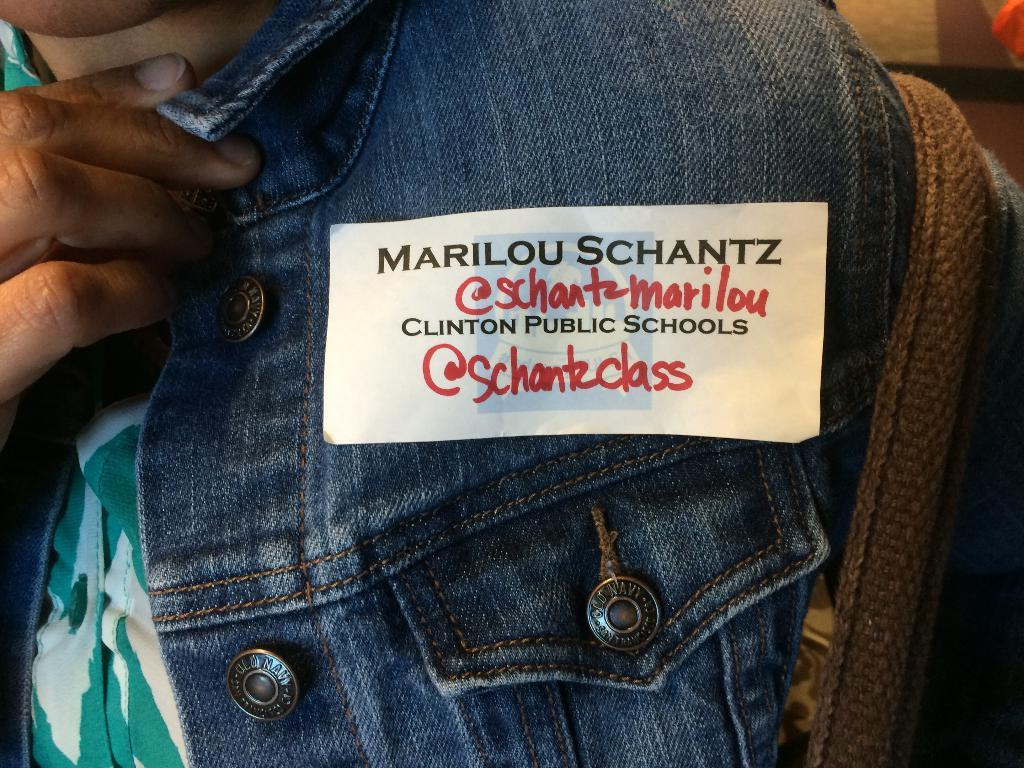Who or what is the main subject in the picture? There is a person in the picture. Can you describe the person's clothing? The person is wearing a blue coat. Is there anything else notable about the person's appearance? Yes, there is a sticker on the coat. What type of treatment is the person receiving for their illness in the image? There is no indication in the image that the person is receiving any treatment for an illness. 